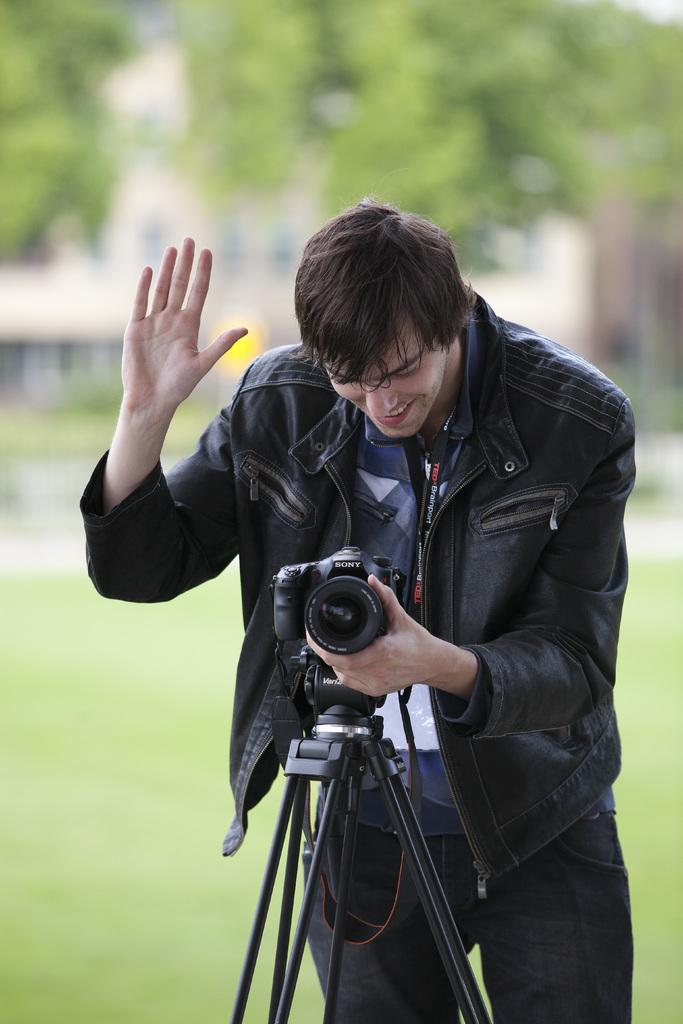What is the main subject of the image? There is a person in the image. What is the person holding in the image? The person is holding a camera. How is the camera positioned in the image? The camera is attached to a stand. Can you describe the background of the image? The background of the image is blurred. What is the annual income of the person in the image? There is no information about the person's income in the image. 